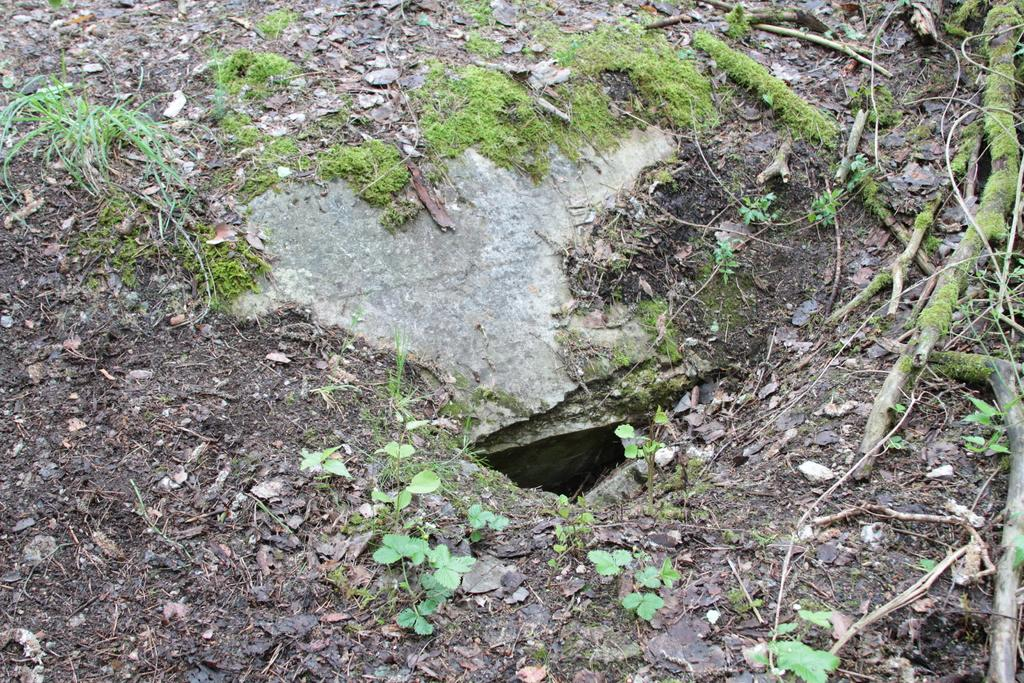What type of vegetation can be seen in the image? There are plants and grass in the image. What other natural elements can be seen in the image? There are twigs and stones in the image. How is the food being cooked in the image? There is no food or cooking activity depicted in the image. 